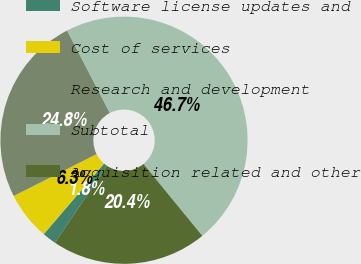Convert chart to OTSL. <chart><loc_0><loc_0><loc_500><loc_500><pie_chart><fcel>Software license updates and<fcel>Cost of services<fcel>Research and development<fcel>Subtotal<fcel>Acquisition related and other<nl><fcel>1.82%<fcel>6.3%<fcel>24.84%<fcel>46.69%<fcel>20.35%<nl></chart> 